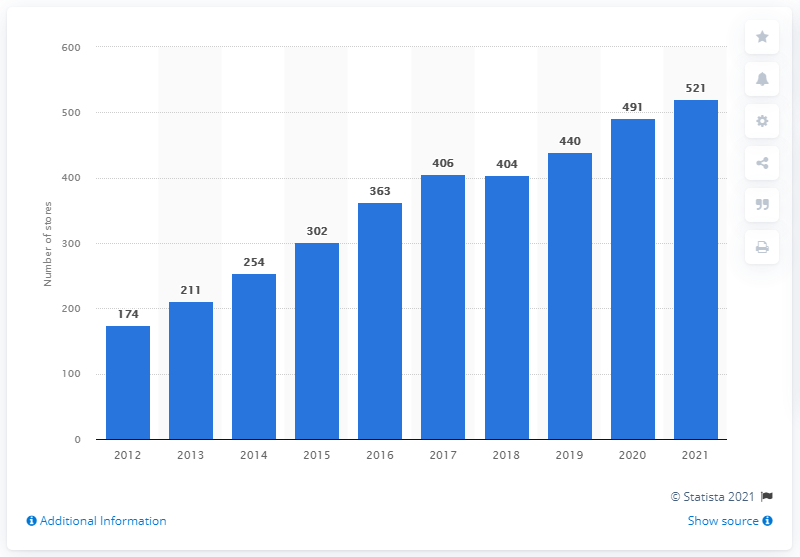Point out several critical features in this image. As of January 31, 2021, lululemon athletica operated a total of 521 stores. 